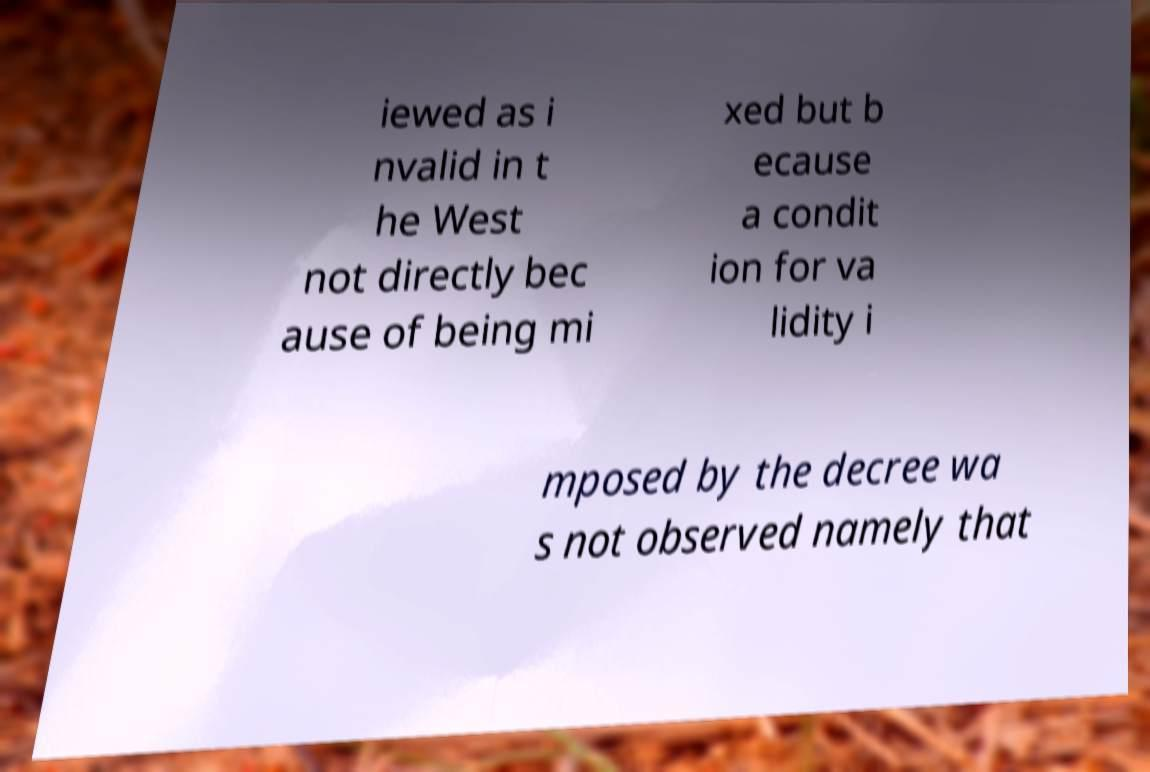Could you assist in decoding the text presented in this image and type it out clearly? iewed as i nvalid in t he West not directly bec ause of being mi xed but b ecause a condit ion for va lidity i mposed by the decree wa s not observed namely that 